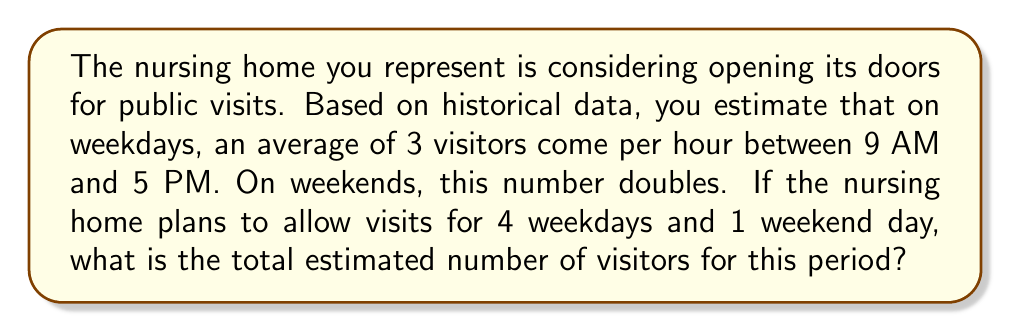Solve this math problem. Let's break this down step-by-step:

1. Calculate visitors for weekdays:
   - Hours per weekday: $5 \text{ PM} - 9 \text{ AM} = 8$ hours
   - Visitors per hour on weekdays: 3
   - Number of weekdays: 4
   - Total weekday visitors: $8 \times 3 \times 4 = 96$

2. Calculate visitors for weekend day:
   - Hours for weekend day: 8 (same as weekday)
   - Visitors per hour on weekends: $3 \times 2 = 6$ (double the weekday rate)
   - Number of weekend days: 1
   - Total weekend visitors: $8 \times 6 \times 1 = 48$

3. Sum up total visitors:
   $\text{Total visitors} = \text{Weekday visitors} + \text{Weekend visitors}$
   $\text{Total visitors} = 96 + 48 = 144$

Therefore, the total estimated number of visitors for this period is 144.
Answer: 144 visitors 